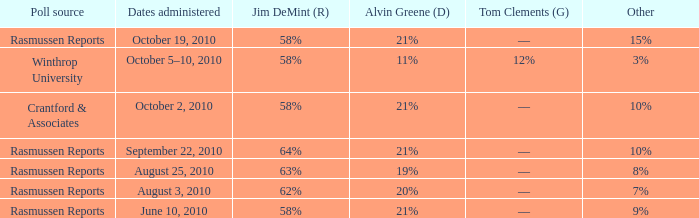What was the vote for Alvin Green when Jim DeMint was 62%? 20%. 